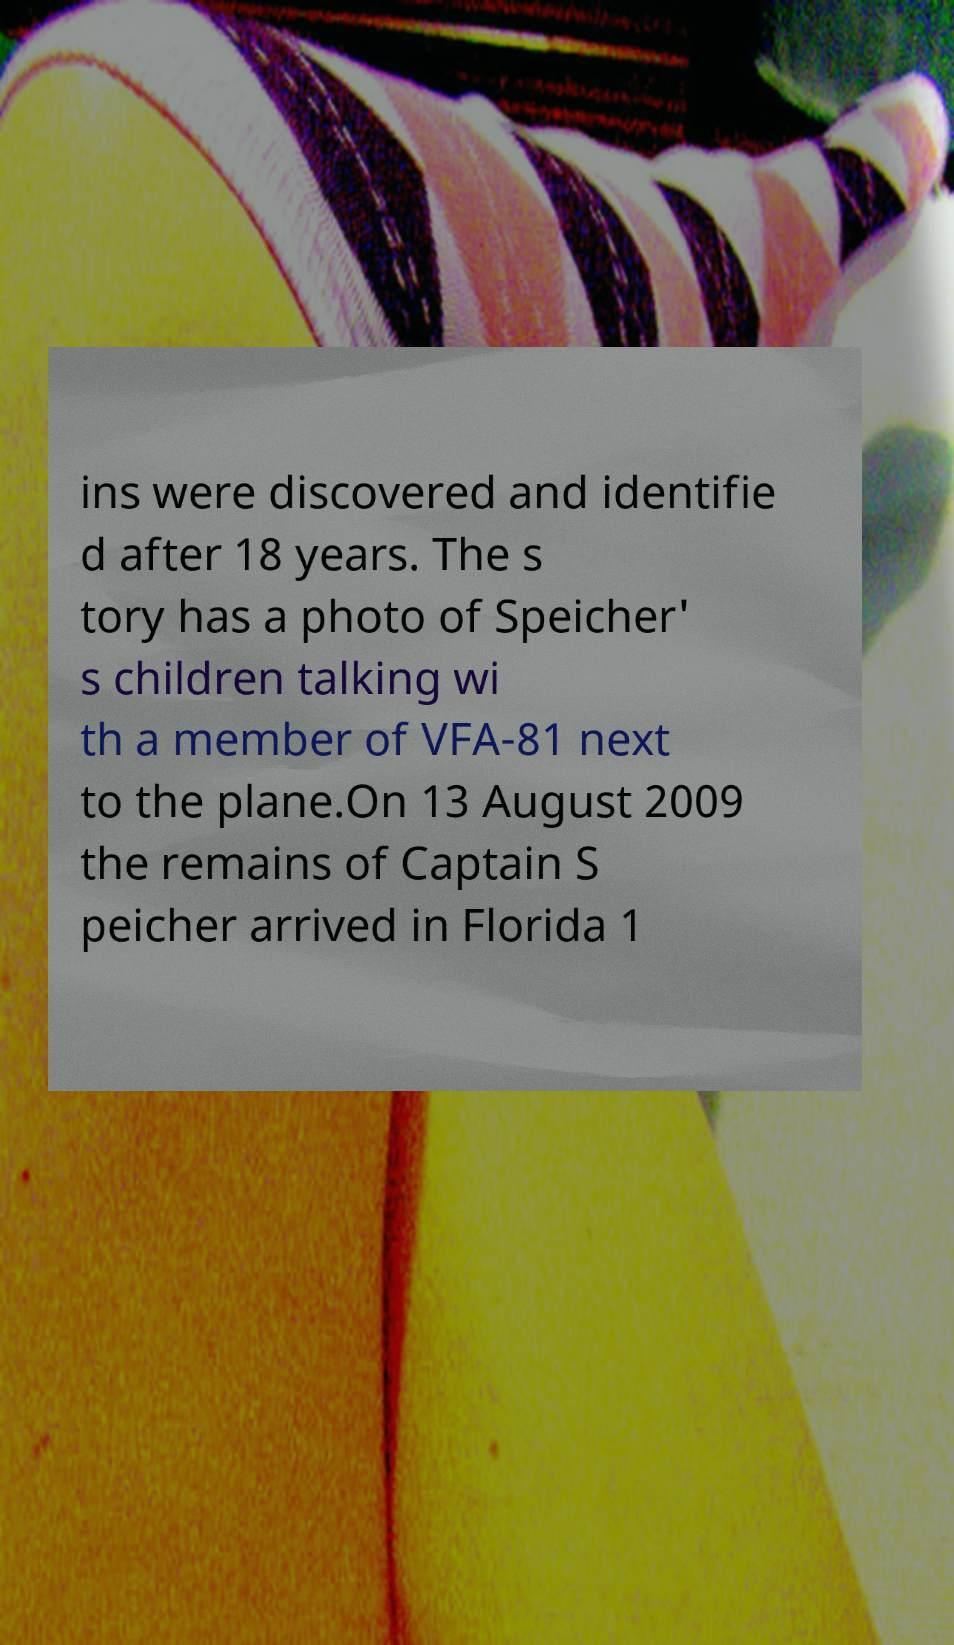Please identify and transcribe the text found in this image. ins were discovered and identifie d after 18 years. The s tory has a photo of Speicher' s children talking wi th a member of VFA-81 next to the plane.On 13 August 2009 the remains of Captain S peicher arrived in Florida 1 